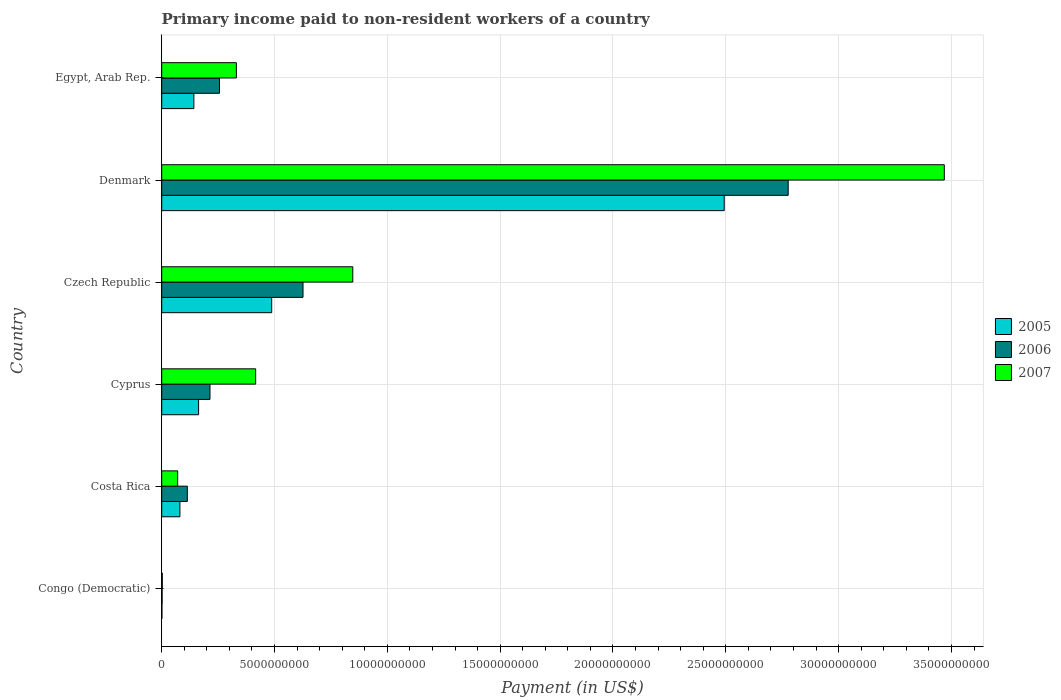How many different coloured bars are there?
Keep it short and to the point. 3. What is the label of the 1st group of bars from the top?
Your answer should be compact. Egypt, Arab Rep. What is the amount paid to workers in 2006 in Cyprus?
Your answer should be compact. 2.14e+09. Across all countries, what is the maximum amount paid to workers in 2007?
Provide a succinct answer. 3.47e+1. Across all countries, what is the minimum amount paid to workers in 2006?
Offer a terse response. 1.77e+07. In which country was the amount paid to workers in 2006 maximum?
Offer a very short reply. Denmark. In which country was the amount paid to workers in 2005 minimum?
Offer a very short reply. Congo (Democratic). What is the total amount paid to workers in 2007 in the graph?
Keep it short and to the point. 5.14e+1. What is the difference between the amount paid to workers in 2005 in Denmark and that in Egypt, Arab Rep.?
Your answer should be compact. 2.35e+1. What is the difference between the amount paid to workers in 2006 in Denmark and the amount paid to workers in 2005 in Costa Rica?
Offer a very short reply. 2.70e+1. What is the average amount paid to workers in 2005 per country?
Provide a succinct answer. 5.61e+09. What is the difference between the amount paid to workers in 2005 and amount paid to workers in 2006 in Czech Republic?
Your answer should be compact. -1.39e+09. What is the ratio of the amount paid to workers in 2006 in Czech Republic to that in Egypt, Arab Rep.?
Provide a short and direct response. 2.45. Is the amount paid to workers in 2006 in Costa Rica less than that in Egypt, Arab Rep.?
Offer a terse response. Yes. What is the difference between the highest and the second highest amount paid to workers in 2007?
Your answer should be very brief. 2.62e+1. What is the difference between the highest and the lowest amount paid to workers in 2005?
Offer a very short reply. 2.49e+1. In how many countries, is the amount paid to workers in 2007 greater than the average amount paid to workers in 2007 taken over all countries?
Your answer should be very brief. 1. Is the sum of the amount paid to workers in 2005 in Congo (Democratic) and Czech Republic greater than the maximum amount paid to workers in 2006 across all countries?
Your answer should be compact. No. What does the 1st bar from the top in Costa Rica represents?
Your answer should be very brief. 2007. What does the 1st bar from the bottom in Cyprus represents?
Provide a short and direct response. 2005. Is it the case that in every country, the sum of the amount paid to workers in 2007 and amount paid to workers in 2005 is greater than the amount paid to workers in 2006?
Provide a short and direct response. Yes. How many bars are there?
Provide a succinct answer. 18. Are all the bars in the graph horizontal?
Provide a succinct answer. Yes. How many countries are there in the graph?
Ensure brevity in your answer.  6. Are the values on the major ticks of X-axis written in scientific E-notation?
Offer a very short reply. No. Does the graph contain any zero values?
Your answer should be very brief. No. Where does the legend appear in the graph?
Keep it short and to the point. Center right. How many legend labels are there?
Your answer should be very brief. 3. How are the legend labels stacked?
Provide a short and direct response. Vertical. What is the title of the graph?
Make the answer very short. Primary income paid to non-resident workers of a country. Does "1967" appear as one of the legend labels in the graph?
Provide a short and direct response. No. What is the label or title of the X-axis?
Provide a succinct answer. Payment (in US$). What is the Payment (in US$) of 2005 in Congo (Democratic)?
Provide a short and direct response. 9.50e+06. What is the Payment (in US$) of 2006 in Congo (Democratic)?
Your answer should be compact. 1.77e+07. What is the Payment (in US$) in 2007 in Congo (Democratic)?
Make the answer very short. 2.60e+07. What is the Payment (in US$) in 2005 in Costa Rica?
Provide a succinct answer. 8.07e+08. What is the Payment (in US$) of 2006 in Costa Rica?
Your answer should be compact. 1.14e+09. What is the Payment (in US$) in 2007 in Costa Rica?
Your response must be concise. 7.08e+08. What is the Payment (in US$) of 2005 in Cyprus?
Provide a succinct answer. 1.63e+09. What is the Payment (in US$) in 2006 in Cyprus?
Ensure brevity in your answer.  2.14e+09. What is the Payment (in US$) in 2007 in Cyprus?
Keep it short and to the point. 4.16e+09. What is the Payment (in US$) of 2005 in Czech Republic?
Keep it short and to the point. 4.87e+09. What is the Payment (in US$) of 2006 in Czech Republic?
Keep it short and to the point. 6.26e+09. What is the Payment (in US$) in 2007 in Czech Republic?
Provide a succinct answer. 8.47e+09. What is the Payment (in US$) in 2005 in Denmark?
Ensure brevity in your answer.  2.49e+1. What is the Payment (in US$) in 2006 in Denmark?
Make the answer very short. 2.78e+1. What is the Payment (in US$) in 2007 in Denmark?
Provide a short and direct response. 3.47e+1. What is the Payment (in US$) of 2005 in Egypt, Arab Rep.?
Provide a succinct answer. 1.43e+09. What is the Payment (in US$) of 2006 in Egypt, Arab Rep.?
Your response must be concise. 2.56e+09. What is the Payment (in US$) of 2007 in Egypt, Arab Rep.?
Provide a short and direct response. 3.31e+09. Across all countries, what is the maximum Payment (in US$) in 2005?
Provide a succinct answer. 2.49e+1. Across all countries, what is the maximum Payment (in US$) of 2006?
Offer a terse response. 2.78e+1. Across all countries, what is the maximum Payment (in US$) in 2007?
Provide a succinct answer. 3.47e+1. Across all countries, what is the minimum Payment (in US$) in 2005?
Offer a very short reply. 9.50e+06. Across all countries, what is the minimum Payment (in US$) in 2006?
Make the answer very short. 1.77e+07. Across all countries, what is the minimum Payment (in US$) in 2007?
Your answer should be very brief. 2.60e+07. What is the total Payment (in US$) of 2005 in the graph?
Your response must be concise. 3.37e+1. What is the total Payment (in US$) in 2006 in the graph?
Provide a succinct answer. 3.99e+1. What is the total Payment (in US$) of 2007 in the graph?
Keep it short and to the point. 5.14e+1. What is the difference between the Payment (in US$) of 2005 in Congo (Democratic) and that in Costa Rica?
Your answer should be very brief. -7.97e+08. What is the difference between the Payment (in US$) in 2006 in Congo (Democratic) and that in Costa Rica?
Give a very brief answer. -1.12e+09. What is the difference between the Payment (in US$) of 2007 in Congo (Democratic) and that in Costa Rica?
Provide a short and direct response. -6.82e+08. What is the difference between the Payment (in US$) of 2005 in Congo (Democratic) and that in Cyprus?
Your answer should be compact. -1.63e+09. What is the difference between the Payment (in US$) in 2006 in Congo (Democratic) and that in Cyprus?
Your response must be concise. -2.12e+09. What is the difference between the Payment (in US$) in 2007 in Congo (Democratic) and that in Cyprus?
Offer a very short reply. -4.14e+09. What is the difference between the Payment (in US$) of 2005 in Congo (Democratic) and that in Czech Republic?
Your response must be concise. -4.87e+09. What is the difference between the Payment (in US$) in 2006 in Congo (Democratic) and that in Czech Republic?
Your answer should be compact. -6.24e+09. What is the difference between the Payment (in US$) in 2007 in Congo (Democratic) and that in Czech Republic?
Offer a terse response. -8.44e+09. What is the difference between the Payment (in US$) in 2005 in Congo (Democratic) and that in Denmark?
Keep it short and to the point. -2.49e+1. What is the difference between the Payment (in US$) of 2006 in Congo (Democratic) and that in Denmark?
Ensure brevity in your answer.  -2.77e+1. What is the difference between the Payment (in US$) in 2007 in Congo (Democratic) and that in Denmark?
Your response must be concise. -3.47e+1. What is the difference between the Payment (in US$) in 2005 in Congo (Democratic) and that in Egypt, Arab Rep.?
Your answer should be very brief. -1.42e+09. What is the difference between the Payment (in US$) of 2006 in Congo (Democratic) and that in Egypt, Arab Rep.?
Offer a terse response. -2.54e+09. What is the difference between the Payment (in US$) of 2007 in Congo (Democratic) and that in Egypt, Arab Rep.?
Offer a very short reply. -3.28e+09. What is the difference between the Payment (in US$) of 2005 in Costa Rica and that in Cyprus?
Give a very brief answer. -8.28e+08. What is the difference between the Payment (in US$) in 2006 in Costa Rica and that in Cyprus?
Give a very brief answer. -1.00e+09. What is the difference between the Payment (in US$) of 2007 in Costa Rica and that in Cyprus?
Your answer should be very brief. -3.46e+09. What is the difference between the Payment (in US$) in 2005 in Costa Rica and that in Czech Republic?
Offer a very short reply. -4.07e+09. What is the difference between the Payment (in US$) of 2006 in Costa Rica and that in Czech Republic?
Keep it short and to the point. -5.13e+09. What is the difference between the Payment (in US$) in 2007 in Costa Rica and that in Czech Republic?
Offer a very short reply. -7.76e+09. What is the difference between the Payment (in US$) of 2005 in Costa Rica and that in Denmark?
Offer a terse response. -2.41e+1. What is the difference between the Payment (in US$) in 2006 in Costa Rica and that in Denmark?
Offer a very short reply. -2.66e+1. What is the difference between the Payment (in US$) in 2007 in Costa Rica and that in Denmark?
Your answer should be very brief. -3.40e+1. What is the difference between the Payment (in US$) in 2005 in Costa Rica and that in Egypt, Arab Rep.?
Provide a short and direct response. -6.19e+08. What is the difference between the Payment (in US$) in 2006 in Costa Rica and that in Egypt, Arab Rep.?
Make the answer very short. -1.43e+09. What is the difference between the Payment (in US$) of 2007 in Costa Rica and that in Egypt, Arab Rep.?
Keep it short and to the point. -2.60e+09. What is the difference between the Payment (in US$) in 2005 in Cyprus and that in Czech Republic?
Provide a short and direct response. -3.24e+09. What is the difference between the Payment (in US$) in 2006 in Cyprus and that in Czech Republic?
Make the answer very short. -4.12e+09. What is the difference between the Payment (in US$) in 2007 in Cyprus and that in Czech Republic?
Ensure brevity in your answer.  -4.30e+09. What is the difference between the Payment (in US$) of 2005 in Cyprus and that in Denmark?
Provide a succinct answer. -2.33e+1. What is the difference between the Payment (in US$) in 2006 in Cyprus and that in Denmark?
Make the answer very short. -2.56e+1. What is the difference between the Payment (in US$) in 2007 in Cyprus and that in Denmark?
Your answer should be compact. -3.05e+1. What is the difference between the Payment (in US$) in 2005 in Cyprus and that in Egypt, Arab Rep.?
Make the answer very short. 2.09e+08. What is the difference between the Payment (in US$) of 2006 in Cyprus and that in Egypt, Arab Rep.?
Offer a very short reply. -4.21e+08. What is the difference between the Payment (in US$) in 2007 in Cyprus and that in Egypt, Arab Rep.?
Give a very brief answer. 8.54e+08. What is the difference between the Payment (in US$) in 2005 in Czech Republic and that in Denmark?
Keep it short and to the point. -2.01e+1. What is the difference between the Payment (in US$) in 2006 in Czech Republic and that in Denmark?
Provide a short and direct response. -2.15e+1. What is the difference between the Payment (in US$) of 2007 in Czech Republic and that in Denmark?
Offer a terse response. -2.62e+1. What is the difference between the Payment (in US$) in 2005 in Czech Republic and that in Egypt, Arab Rep.?
Offer a very short reply. 3.45e+09. What is the difference between the Payment (in US$) in 2006 in Czech Republic and that in Egypt, Arab Rep.?
Your answer should be compact. 3.70e+09. What is the difference between the Payment (in US$) of 2007 in Czech Republic and that in Egypt, Arab Rep.?
Provide a short and direct response. 5.16e+09. What is the difference between the Payment (in US$) of 2005 in Denmark and that in Egypt, Arab Rep.?
Make the answer very short. 2.35e+1. What is the difference between the Payment (in US$) of 2006 in Denmark and that in Egypt, Arab Rep.?
Offer a very short reply. 2.52e+1. What is the difference between the Payment (in US$) of 2007 in Denmark and that in Egypt, Arab Rep.?
Ensure brevity in your answer.  3.14e+1. What is the difference between the Payment (in US$) in 2005 in Congo (Democratic) and the Payment (in US$) in 2006 in Costa Rica?
Offer a very short reply. -1.13e+09. What is the difference between the Payment (in US$) in 2005 in Congo (Democratic) and the Payment (in US$) in 2007 in Costa Rica?
Provide a succinct answer. -6.98e+08. What is the difference between the Payment (in US$) in 2006 in Congo (Democratic) and the Payment (in US$) in 2007 in Costa Rica?
Your response must be concise. -6.90e+08. What is the difference between the Payment (in US$) in 2005 in Congo (Democratic) and the Payment (in US$) in 2006 in Cyprus?
Offer a very short reply. -2.13e+09. What is the difference between the Payment (in US$) in 2005 in Congo (Democratic) and the Payment (in US$) in 2007 in Cyprus?
Your answer should be very brief. -4.15e+09. What is the difference between the Payment (in US$) in 2006 in Congo (Democratic) and the Payment (in US$) in 2007 in Cyprus?
Your answer should be very brief. -4.15e+09. What is the difference between the Payment (in US$) in 2005 in Congo (Democratic) and the Payment (in US$) in 2006 in Czech Republic?
Make the answer very short. -6.25e+09. What is the difference between the Payment (in US$) in 2005 in Congo (Democratic) and the Payment (in US$) in 2007 in Czech Republic?
Provide a succinct answer. -8.46e+09. What is the difference between the Payment (in US$) of 2006 in Congo (Democratic) and the Payment (in US$) of 2007 in Czech Republic?
Make the answer very short. -8.45e+09. What is the difference between the Payment (in US$) in 2005 in Congo (Democratic) and the Payment (in US$) in 2006 in Denmark?
Your response must be concise. -2.78e+1. What is the difference between the Payment (in US$) of 2005 in Congo (Democratic) and the Payment (in US$) of 2007 in Denmark?
Give a very brief answer. -3.47e+1. What is the difference between the Payment (in US$) in 2006 in Congo (Democratic) and the Payment (in US$) in 2007 in Denmark?
Provide a short and direct response. -3.47e+1. What is the difference between the Payment (in US$) in 2005 in Congo (Democratic) and the Payment (in US$) in 2006 in Egypt, Arab Rep.?
Your response must be concise. -2.55e+09. What is the difference between the Payment (in US$) in 2005 in Congo (Democratic) and the Payment (in US$) in 2007 in Egypt, Arab Rep.?
Provide a short and direct response. -3.30e+09. What is the difference between the Payment (in US$) of 2006 in Congo (Democratic) and the Payment (in US$) of 2007 in Egypt, Arab Rep.?
Provide a succinct answer. -3.29e+09. What is the difference between the Payment (in US$) of 2005 in Costa Rica and the Payment (in US$) of 2006 in Cyprus?
Make the answer very short. -1.33e+09. What is the difference between the Payment (in US$) in 2005 in Costa Rica and the Payment (in US$) in 2007 in Cyprus?
Your answer should be very brief. -3.36e+09. What is the difference between the Payment (in US$) in 2006 in Costa Rica and the Payment (in US$) in 2007 in Cyprus?
Give a very brief answer. -3.03e+09. What is the difference between the Payment (in US$) in 2005 in Costa Rica and the Payment (in US$) in 2006 in Czech Republic?
Your answer should be very brief. -5.46e+09. What is the difference between the Payment (in US$) in 2005 in Costa Rica and the Payment (in US$) in 2007 in Czech Republic?
Provide a succinct answer. -7.66e+09. What is the difference between the Payment (in US$) of 2006 in Costa Rica and the Payment (in US$) of 2007 in Czech Republic?
Offer a very short reply. -7.33e+09. What is the difference between the Payment (in US$) in 2005 in Costa Rica and the Payment (in US$) in 2006 in Denmark?
Make the answer very short. -2.70e+1. What is the difference between the Payment (in US$) of 2005 in Costa Rica and the Payment (in US$) of 2007 in Denmark?
Ensure brevity in your answer.  -3.39e+1. What is the difference between the Payment (in US$) of 2006 in Costa Rica and the Payment (in US$) of 2007 in Denmark?
Your answer should be compact. -3.35e+1. What is the difference between the Payment (in US$) in 2005 in Costa Rica and the Payment (in US$) in 2006 in Egypt, Arab Rep.?
Give a very brief answer. -1.75e+09. What is the difference between the Payment (in US$) in 2005 in Costa Rica and the Payment (in US$) in 2007 in Egypt, Arab Rep.?
Your answer should be very brief. -2.50e+09. What is the difference between the Payment (in US$) of 2006 in Costa Rica and the Payment (in US$) of 2007 in Egypt, Arab Rep.?
Your response must be concise. -2.17e+09. What is the difference between the Payment (in US$) of 2005 in Cyprus and the Payment (in US$) of 2006 in Czech Republic?
Ensure brevity in your answer.  -4.63e+09. What is the difference between the Payment (in US$) of 2005 in Cyprus and the Payment (in US$) of 2007 in Czech Republic?
Make the answer very short. -6.83e+09. What is the difference between the Payment (in US$) in 2006 in Cyprus and the Payment (in US$) in 2007 in Czech Republic?
Offer a very short reply. -6.33e+09. What is the difference between the Payment (in US$) of 2005 in Cyprus and the Payment (in US$) of 2006 in Denmark?
Your answer should be very brief. -2.61e+1. What is the difference between the Payment (in US$) of 2005 in Cyprus and the Payment (in US$) of 2007 in Denmark?
Your response must be concise. -3.30e+1. What is the difference between the Payment (in US$) in 2006 in Cyprus and the Payment (in US$) in 2007 in Denmark?
Provide a succinct answer. -3.25e+1. What is the difference between the Payment (in US$) in 2005 in Cyprus and the Payment (in US$) in 2006 in Egypt, Arab Rep.?
Offer a terse response. -9.26e+08. What is the difference between the Payment (in US$) in 2005 in Cyprus and the Payment (in US$) in 2007 in Egypt, Arab Rep.?
Keep it short and to the point. -1.67e+09. What is the difference between the Payment (in US$) in 2006 in Cyprus and the Payment (in US$) in 2007 in Egypt, Arab Rep.?
Provide a short and direct response. -1.17e+09. What is the difference between the Payment (in US$) in 2005 in Czech Republic and the Payment (in US$) in 2006 in Denmark?
Offer a very short reply. -2.29e+1. What is the difference between the Payment (in US$) in 2005 in Czech Republic and the Payment (in US$) in 2007 in Denmark?
Ensure brevity in your answer.  -2.98e+1. What is the difference between the Payment (in US$) of 2006 in Czech Republic and the Payment (in US$) of 2007 in Denmark?
Make the answer very short. -2.84e+1. What is the difference between the Payment (in US$) in 2005 in Czech Republic and the Payment (in US$) in 2006 in Egypt, Arab Rep.?
Your answer should be compact. 2.31e+09. What is the difference between the Payment (in US$) of 2005 in Czech Republic and the Payment (in US$) of 2007 in Egypt, Arab Rep.?
Offer a terse response. 1.57e+09. What is the difference between the Payment (in US$) in 2006 in Czech Republic and the Payment (in US$) in 2007 in Egypt, Arab Rep.?
Your answer should be compact. 2.95e+09. What is the difference between the Payment (in US$) in 2005 in Denmark and the Payment (in US$) in 2006 in Egypt, Arab Rep.?
Your answer should be very brief. 2.24e+1. What is the difference between the Payment (in US$) in 2005 in Denmark and the Payment (in US$) in 2007 in Egypt, Arab Rep.?
Offer a terse response. 2.16e+1. What is the difference between the Payment (in US$) in 2006 in Denmark and the Payment (in US$) in 2007 in Egypt, Arab Rep.?
Offer a very short reply. 2.45e+1. What is the average Payment (in US$) in 2005 per country?
Offer a very short reply. 5.61e+09. What is the average Payment (in US$) of 2006 per country?
Provide a short and direct response. 6.65e+09. What is the average Payment (in US$) in 2007 per country?
Make the answer very short. 8.56e+09. What is the difference between the Payment (in US$) in 2005 and Payment (in US$) in 2006 in Congo (Democratic)?
Provide a short and direct response. -8.20e+06. What is the difference between the Payment (in US$) of 2005 and Payment (in US$) of 2007 in Congo (Democratic)?
Your answer should be compact. -1.65e+07. What is the difference between the Payment (in US$) in 2006 and Payment (in US$) in 2007 in Congo (Democratic)?
Keep it short and to the point. -8.30e+06. What is the difference between the Payment (in US$) of 2005 and Payment (in US$) of 2006 in Costa Rica?
Give a very brief answer. -3.28e+08. What is the difference between the Payment (in US$) of 2005 and Payment (in US$) of 2007 in Costa Rica?
Your response must be concise. 9.92e+07. What is the difference between the Payment (in US$) of 2006 and Payment (in US$) of 2007 in Costa Rica?
Your answer should be compact. 4.27e+08. What is the difference between the Payment (in US$) in 2005 and Payment (in US$) in 2006 in Cyprus?
Keep it short and to the point. -5.04e+08. What is the difference between the Payment (in US$) in 2005 and Payment (in US$) in 2007 in Cyprus?
Your response must be concise. -2.53e+09. What is the difference between the Payment (in US$) of 2006 and Payment (in US$) of 2007 in Cyprus?
Ensure brevity in your answer.  -2.02e+09. What is the difference between the Payment (in US$) in 2005 and Payment (in US$) in 2006 in Czech Republic?
Make the answer very short. -1.39e+09. What is the difference between the Payment (in US$) of 2005 and Payment (in US$) of 2007 in Czech Republic?
Offer a very short reply. -3.59e+09. What is the difference between the Payment (in US$) of 2006 and Payment (in US$) of 2007 in Czech Republic?
Your answer should be very brief. -2.21e+09. What is the difference between the Payment (in US$) in 2005 and Payment (in US$) in 2006 in Denmark?
Keep it short and to the point. -2.84e+09. What is the difference between the Payment (in US$) in 2005 and Payment (in US$) in 2007 in Denmark?
Your response must be concise. -9.75e+09. What is the difference between the Payment (in US$) in 2006 and Payment (in US$) in 2007 in Denmark?
Offer a terse response. -6.92e+09. What is the difference between the Payment (in US$) of 2005 and Payment (in US$) of 2006 in Egypt, Arab Rep.?
Give a very brief answer. -1.14e+09. What is the difference between the Payment (in US$) of 2005 and Payment (in US$) of 2007 in Egypt, Arab Rep.?
Provide a short and direct response. -1.88e+09. What is the difference between the Payment (in US$) in 2006 and Payment (in US$) in 2007 in Egypt, Arab Rep.?
Your response must be concise. -7.49e+08. What is the ratio of the Payment (in US$) of 2005 in Congo (Democratic) to that in Costa Rica?
Your answer should be very brief. 0.01. What is the ratio of the Payment (in US$) of 2006 in Congo (Democratic) to that in Costa Rica?
Your answer should be compact. 0.02. What is the ratio of the Payment (in US$) of 2007 in Congo (Democratic) to that in Costa Rica?
Your answer should be very brief. 0.04. What is the ratio of the Payment (in US$) in 2005 in Congo (Democratic) to that in Cyprus?
Give a very brief answer. 0.01. What is the ratio of the Payment (in US$) of 2006 in Congo (Democratic) to that in Cyprus?
Give a very brief answer. 0.01. What is the ratio of the Payment (in US$) of 2007 in Congo (Democratic) to that in Cyprus?
Ensure brevity in your answer.  0.01. What is the ratio of the Payment (in US$) of 2005 in Congo (Democratic) to that in Czech Republic?
Your response must be concise. 0. What is the ratio of the Payment (in US$) of 2006 in Congo (Democratic) to that in Czech Republic?
Your answer should be compact. 0. What is the ratio of the Payment (in US$) of 2007 in Congo (Democratic) to that in Czech Republic?
Offer a very short reply. 0. What is the ratio of the Payment (in US$) in 2006 in Congo (Democratic) to that in Denmark?
Make the answer very short. 0. What is the ratio of the Payment (in US$) in 2007 in Congo (Democratic) to that in Denmark?
Ensure brevity in your answer.  0. What is the ratio of the Payment (in US$) of 2005 in Congo (Democratic) to that in Egypt, Arab Rep.?
Make the answer very short. 0.01. What is the ratio of the Payment (in US$) of 2006 in Congo (Democratic) to that in Egypt, Arab Rep.?
Make the answer very short. 0.01. What is the ratio of the Payment (in US$) of 2007 in Congo (Democratic) to that in Egypt, Arab Rep.?
Provide a short and direct response. 0.01. What is the ratio of the Payment (in US$) in 2005 in Costa Rica to that in Cyprus?
Your response must be concise. 0.49. What is the ratio of the Payment (in US$) of 2006 in Costa Rica to that in Cyprus?
Your answer should be very brief. 0.53. What is the ratio of the Payment (in US$) of 2007 in Costa Rica to that in Cyprus?
Provide a succinct answer. 0.17. What is the ratio of the Payment (in US$) of 2005 in Costa Rica to that in Czech Republic?
Your response must be concise. 0.17. What is the ratio of the Payment (in US$) of 2006 in Costa Rica to that in Czech Republic?
Provide a succinct answer. 0.18. What is the ratio of the Payment (in US$) of 2007 in Costa Rica to that in Czech Republic?
Provide a succinct answer. 0.08. What is the ratio of the Payment (in US$) of 2005 in Costa Rica to that in Denmark?
Keep it short and to the point. 0.03. What is the ratio of the Payment (in US$) of 2006 in Costa Rica to that in Denmark?
Make the answer very short. 0.04. What is the ratio of the Payment (in US$) of 2007 in Costa Rica to that in Denmark?
Give a very brief answer. 0.02. What is the ratio of the Payment (in US$) in 2005 in Costa Rica to that in Egypt, Arab Rep.?
Offer a very short reply. 0.57. What is the ratio of the Payment (in US$) in 2006 in Costa Rica to that in Egypt, Arab Rep.?
Make the answer very short. 0.44. What is the ratio of the Payment (in US$) of 2007 in Costa Rica to that in Egypt, Arab Rep.?
Provide a succinct answer. 0.21. What is the ratio of the Payment (in US$) in 2005 in Cyprus to that in Czech Republic?
Your answer should be compact. 0.34. What is the ratio of the Payment (in US$) of 2006 in Cyprus to that in Czech Republic?
Offer a terse response. 0.34. What is the ratio of the Payment (in US$) in 2007 in Cyprus to that in Czech Republic?
Make the answer very short. 0.49. What is the ratio of the Payment (in US$) of 2005 in Cyprus to that in Denmark?
Offer a terse response. 0.07. What is the ratio of the Payment (in US$) of 2006 in Cyprus to that in Denmark?
Offer a terse response. 0.08. What is the ratio of the Payment (in US$) in 2007 in Cyprus to that in Denmark?
Keep it short and to the point. 0.12. What is the ratio of the Payment (in US$) of 2005 in Cyprus to that in Egypt, Arab Rep.?
Provide a succinct answer. 1.15. What is the ratio of the Payment (in US$) of 2006 in Cyprus to that in Egypt, Arab Rep.?
Make the answer very short. 0.84. What is the ratio of the Payment (in US$) of 2007 in Cyprus to that in Egypt, Arab Rep.?
Your response must be concise. 1.26. What is the ratio of the Payment (in US$) in 2005 in Czech Republic to that in Denmark?
Your response must be concise. 0.2. What is the ratio of the Payment (in US$) of 2006 in Czech Republic to that in Denmark?
Offer a very short reply. 0.23. What is the ratio of the Payment (in US$) of 2007 in Czech Republic to that in Denmark?
Provide a succinct answer. 0.24. What is the ratio of the Payment (in US$) in 2005 in Czech Republic to that in Egypt, Arab Rep.?
Make the answer very short. 3.42. What is the ratio of the Payment (in US$) in 2006 in Czech Republic to that in Egypt, Arab Rep.?
Keep it short and to the point. 2.45. What is the ratio of the Payment (in US$) of 2007 in Czech Republic to that in Egypt, Arab Rep.?
Provide a succinct answer. 2.56. What is the ratio of the Payment (in US$) in 2005 in Denmark to that in Egypt, Arab Rep.?
Provide a succinct answer. 17.49. What is the ratio of the Payment (in US$) in 2006 in Denmark to that in Egypt, Arab Rep.?
Offer a terse response. 10.84. What is the ratio of the Payment (in US$) in 2007 in Denmark to that in Egypt, Arab Rep.?
Your answer should be compact. 10.48. What is the difference between the highest and the second highest Payment (in US$) in 2005?
Give a very brief answer. 2.01e+1. What is the difference between the highest and the second highest Payment (in US$) of 2006?
Your answer should be very brief. 2.15e+1. What is the difference between the highest and the second highest Payment (in US$) in 2007?
Offer a very short reply. 2.62e+1. What is the difference between the highest and the lowest Payment (in US$) in 2005?
Offer a terse response. 2.49e+1. What is the difference between the highest and the lowest Payment (in US$) in 2006?
Your response must be concise. 2.77e+1. What is the difference between the highest and the lowest Payment (in US$) of 2007?
Offer a very short reply. 3.47e+1. 